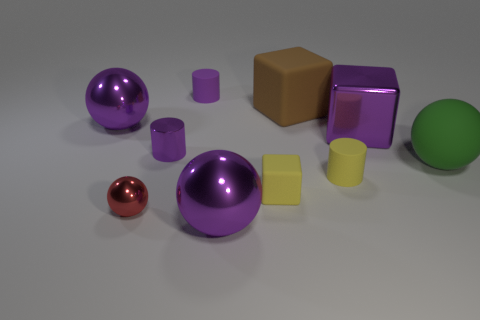How many other objects are the same color as the small matte block?
Your answer should be very brief. 1. What number of tiny purple things are there?
Your answer should be compact. 2. Are there fewer big rubber things to the left of the large brown rubber cube than tiny things?
Offer a very short reply. Yes. Is the large ball that is in front of the small yellow matte cylinder made of the same material as the large brown cube?
Your answer should be very brief. No. There is a tiny purple thing that is to the right of the small purple thing that is on the left side of the small purple cylinder behind the purple metallic cylinder; what shape is it?
Provide a succinct answer. Cylinder. Is there a purple block that has the same size as the brown rubber thing?
Make the answer very short. Yes. The rubber ball has what size?
Give a very brief answer. Large. How many yellow matte things have the same size as the red sphere?
Your answer should be compact. 2. Is the number of purple spheres in front of the small yellow cylinder less than the number of rubber blocks that are in front of the tiny red metallic ball?
Provide a succinct answer. No. What size is the matte cylinder that is in front of the large purple shiny object that is left of the big shiny sphere in front of the small yellow cube?
Provide a succinct answer. Small. 